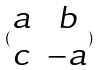<formula> <loc_0><loc_0><loc_500><loc_500>( \begin{matrix} a & b \\ c & - a \end{matrix} )</formula> 